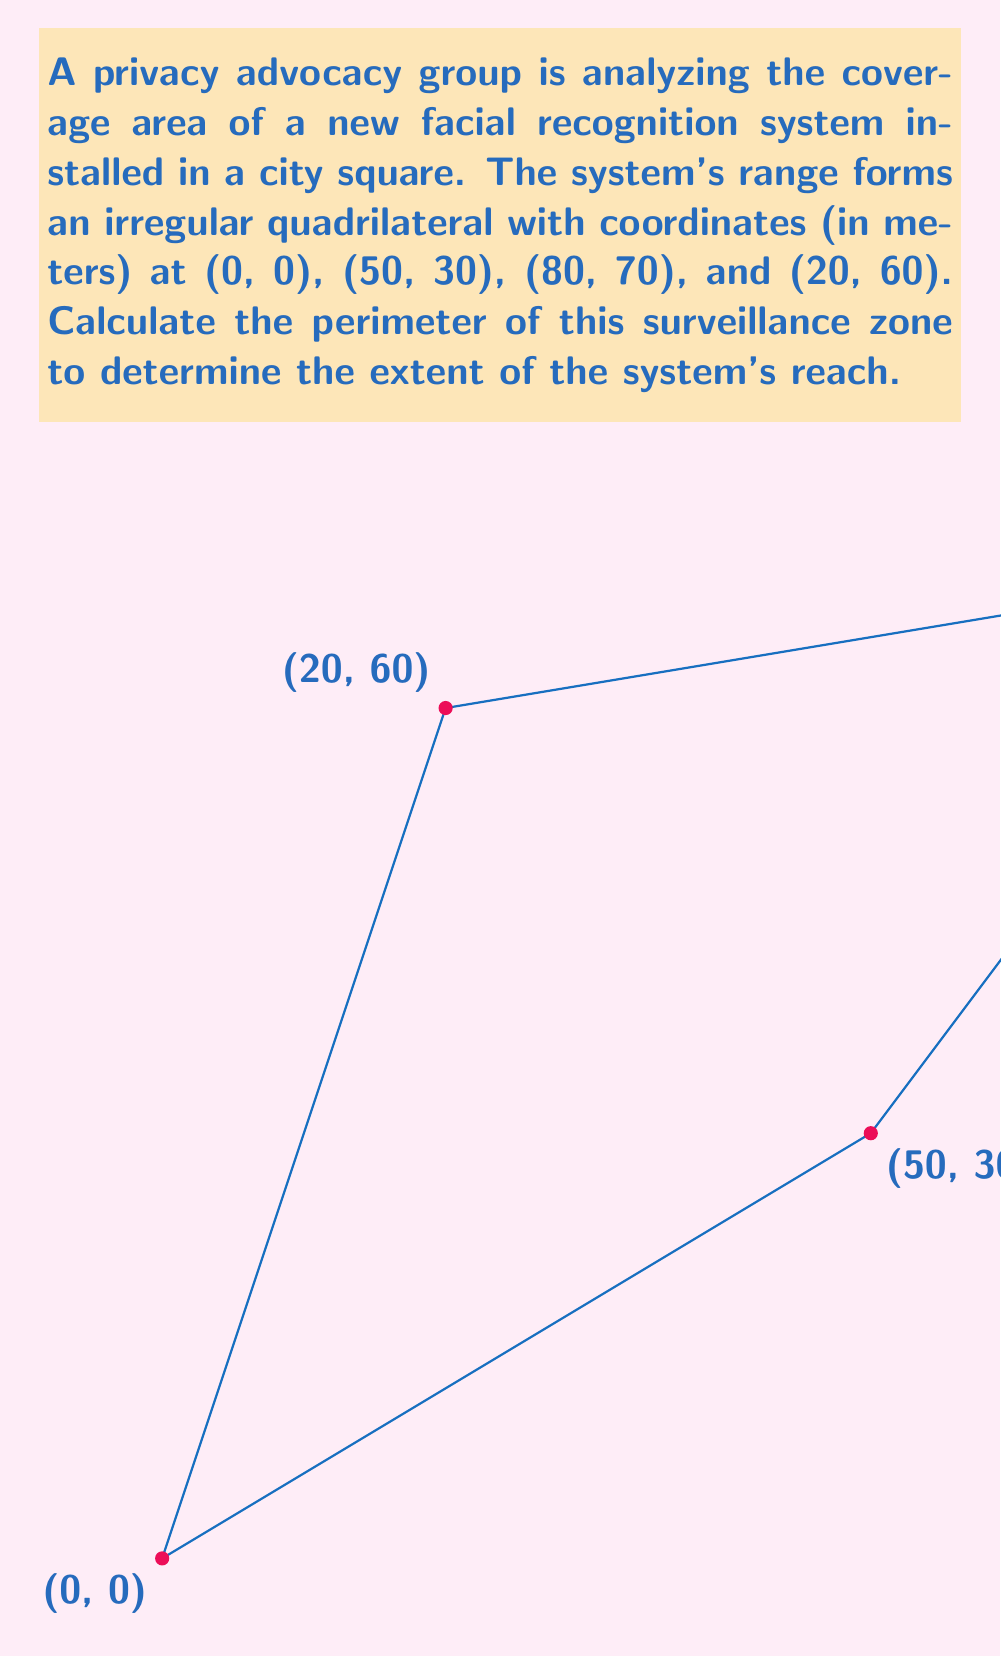Give your solution to this math problem. To compute the perimeter of the irregular quadrilateral, we need to calculate the distance between each pair of consecutive points and sum them up. We'll use the distance formula between two points $(x_1, y_1)$ and $(x_2, y_2)$:

$$d = \sqrt{(x_2 - x_1)^2 + (y_2 - y_1)^2}$$

1. Distance from (0, 0) to (50, 30):
   $$d_1 = \sqrt{(50 - 0)^2 + (30 - 0)^2} = \sqrt{2500 + 900} = \sqrt{3400} \approx 58.31 \text{ m}$$

2. Distance from (50, 30) to (80, 70):
   $$d_2 = \sqrt{(80 - 50)^2 + (70 - 30)^2} = \sqrt{900 + 1600} = \sqrt{2500} = 50 \text{ m}$$

3. Distance from (80, 70) to (20, 60):
   $$d_3 = \sqrt{(20 - 80)^2 + (60 - 70)^2} = \sqrt{3600 + 100} = \sqrt{3700} \approx 60.83 \text{ m}$$

4. Distance from (20, 60) to (0, 0):
   $$d_4 = \sqrt{(0 - 20)^2 + (0 - 60)^2} = \sqrt{400 + 3600} = \sqrt{4000} \approx 63.25 \text{ m}$$

5. Sum up all distances to get the perimeter:
   $$\text{Perimeter} = d_1 + d_2 + d_3 + d_4 \approx 58.31 + 50 + 60.83 + 63.25 = 232.39 \text{ m}$$
Answer: $232.39 \text{ m}$ 